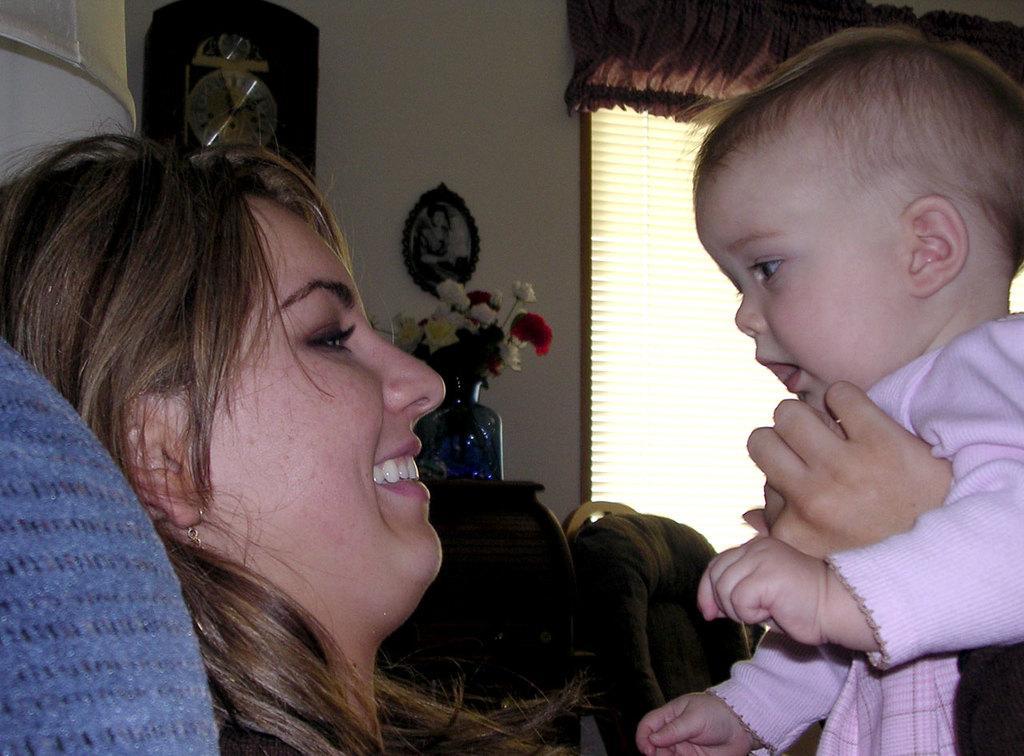In one or two sentences, can you explain what this image depicts? In the image in the center, we can see one woman sitting and holding one baby. And she is smiling, which we can see on her face. In the background there is a wall, window, curtain, flower vase, photo frame, chair and flowers. 